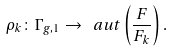<formula> <loc_0><loc_0><loc_500><loc_500>\rho _ { k } \colon \Gamma _ { g , 1 } \rightarrow \ a u t \left ( \frac { F } { F _ { k } } \right ) .</formula> 